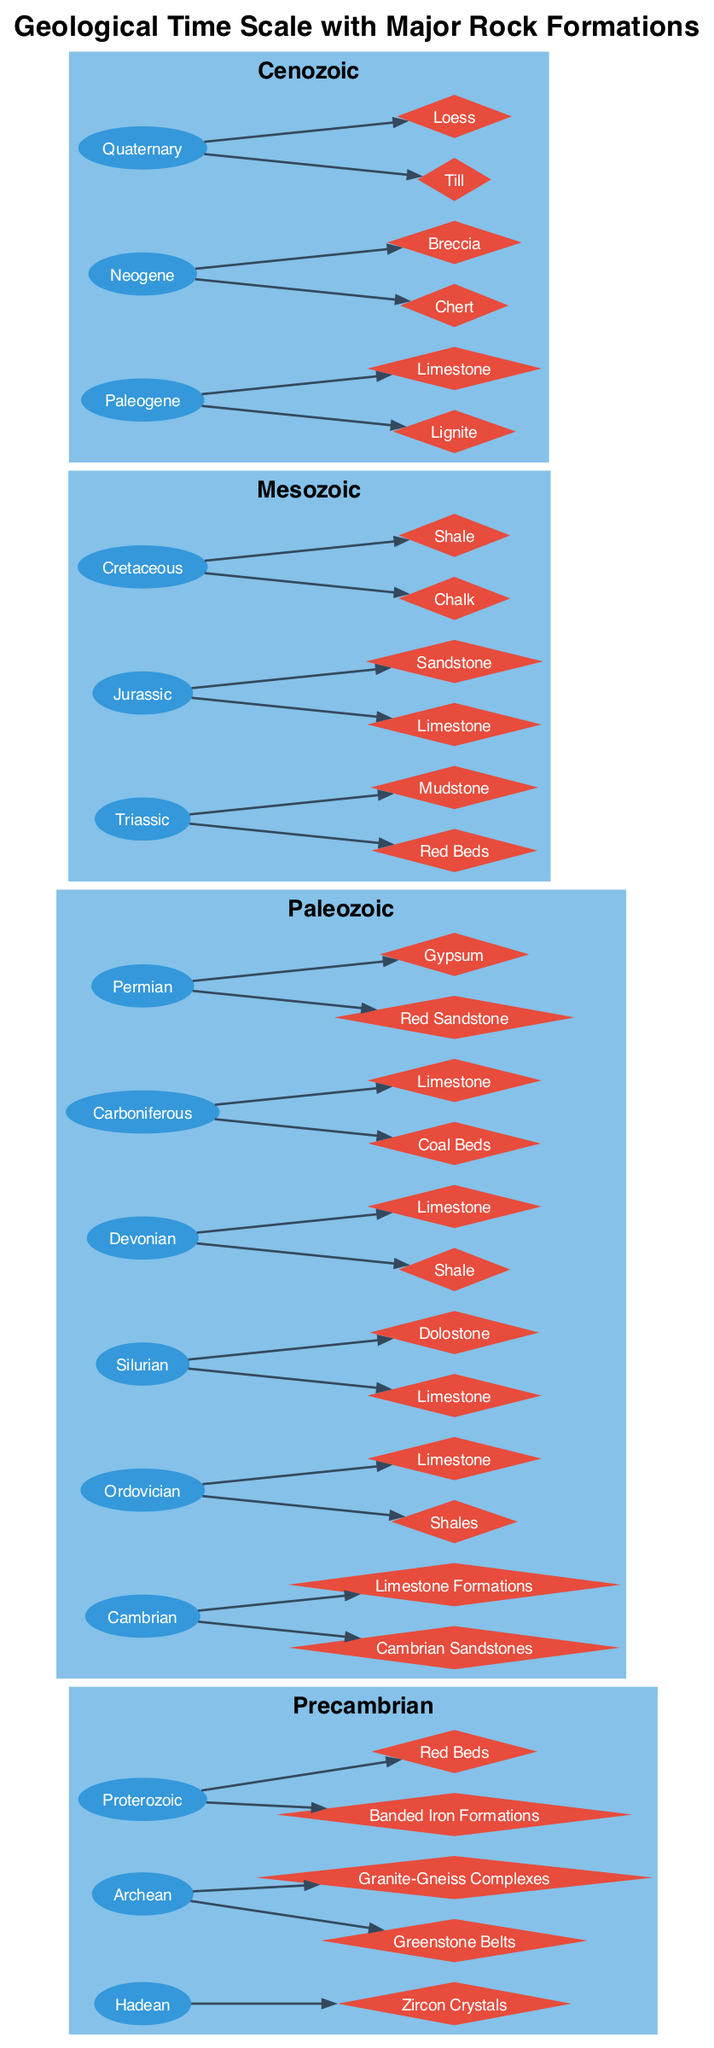What era does the limestone in the Jurassic period belong to? The diagram shows that the Jurassic period is located under the Mesozoic era. Each period, including Jurassic, is categorized under its corresponding era. Therefore, the limestone in the Jurassic period is part of the Mesozoic era.
Answer: Mesozoic How many rock types are listed under the Cambrian period? Upon examining the Cambrian period in the Paleozoic era, there are two rock types listed: Cambrian Sandstones and Limestone Formations. Thus, the total count of rock types is two.
Answer: 2 Which rock formation is associated with the Ordovician period? The diagram indicates that the Ordovician period features two rock types: Shales and Limestone. This can be verified by locating the node for the Ordovician period and observing which rock formations are linked to it.
Answer: Shales and Limestone In which period can you find Banded Iron Formations? The Banded Iron Formations are associated with the Proterozoic period. By analyzing the diagram, I find that Proterozoic is part of the Precambrian era, where Banded Iron Formations are explicitly indicated as one of the rock types under that period.
Answer: Proterozoic What are the rock types listed under the Quaternary period? To identify the rock types under the Quaternary period, I look for the node representing Quaternary in the Cenozoic era. It displays two rock types: Till and Loess. Therefore, the answer includes both rock types represented within that period.
Answer: Till and Loess Which era contains the majority of coal-related rock formations? The diagram shows that the Carboniferous period, which is part of the Paleozoic era, includes Coal Beds as one of its rock types. While there are other periods with specific rocks, Carboniferous stands out for its association with coal. Hence, it is the era containing coal-related formations.
Answer: Paleozoic Name a rock formation from the Mesozoic era. The Mesozoic era, as illustrated in the diagram, includes several periods—Triassic, Jurassic, and Cretaceous. Each of these has associated rock formations; for example, in the Jurassic period, limestone is highlighted as a rock formation. Thus, any of the listed formations can serve as an answer.
Answer: Limestone How many periods are found in the Paleozoic era? By investigating the diagram, I see that the Paleozoic era is divided into six distinct periods: Cambrian, Ordovician, Silurian, Devonian, Carboniferous, and Permian. Counting these gives a total of six periods within the Paleozoic era.
Answer: 6 What color is used for the rock formations in the diagram? The nodes for the rock formations, represented as diamonds in the diagram, have been assigned the color #E74C3C. This is explicitly described in the diagram's coding attributes for nodes depicting rock formations.
Answer: Red 